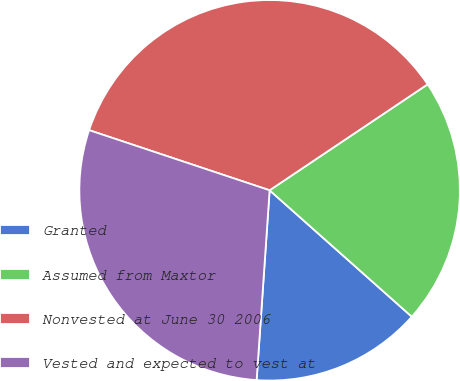<chart> <loc_0><loc_0><loc_500><loc_500><pie_chart><fcel>Granted<fcel>Assumed from Maxtor<fcel>Nonvested at June 30 2006<fcel>Vested and expected to vest at<nl><fcel>14.52%<fcel>20.97%<fcel>35.48%<fcel>29.03%<nl></chart> 